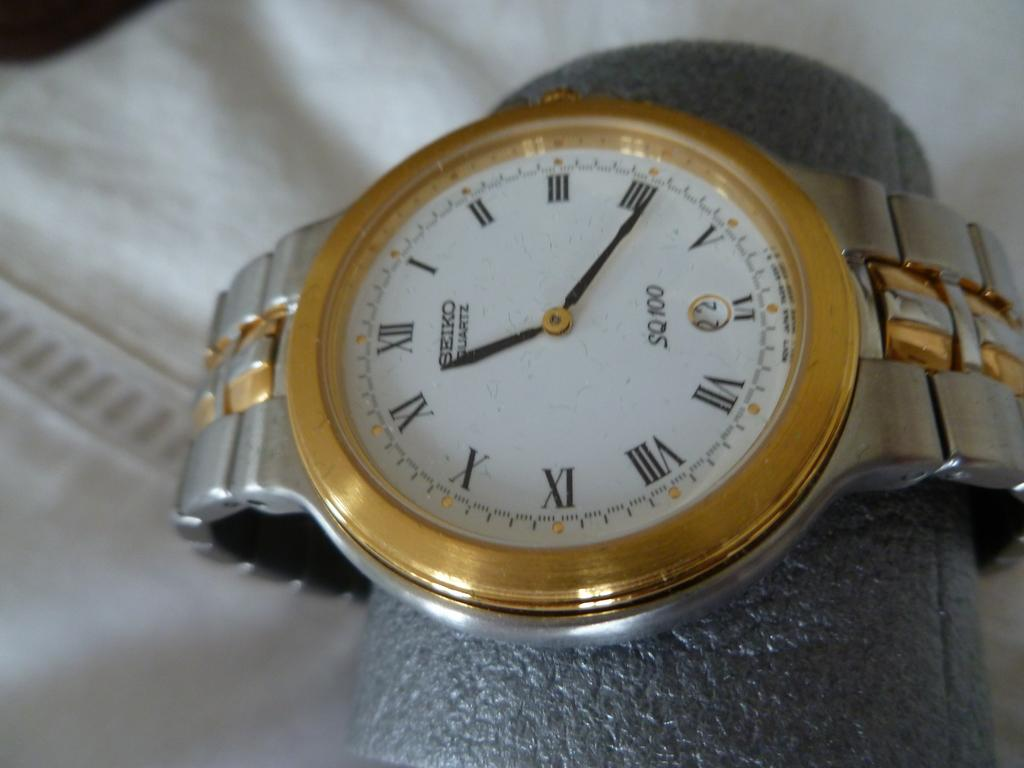Provide a one-sentence caption for the provided image. a gold and white seiko watch and roman numeral clock. 